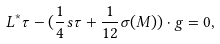<formula> <loc_0><loc_0><loc_500><loc_500>L ^ { * } \tau - ( \frac { 1 } { 4 } s \tau + \frac { 1 } { 1 2 } \sigma ( M ) ) \cdot g = 0 ,</formula> 